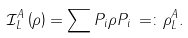<formula> <loc_0><loc_0><loc_500><loc_500>\mathcal { I } _ { L } ^ { A } \left ( \rho \right ) = \sum P _ { i } \rho P _ { i } \, = \colon \rho _ { L } ^ { A } .</formula> 